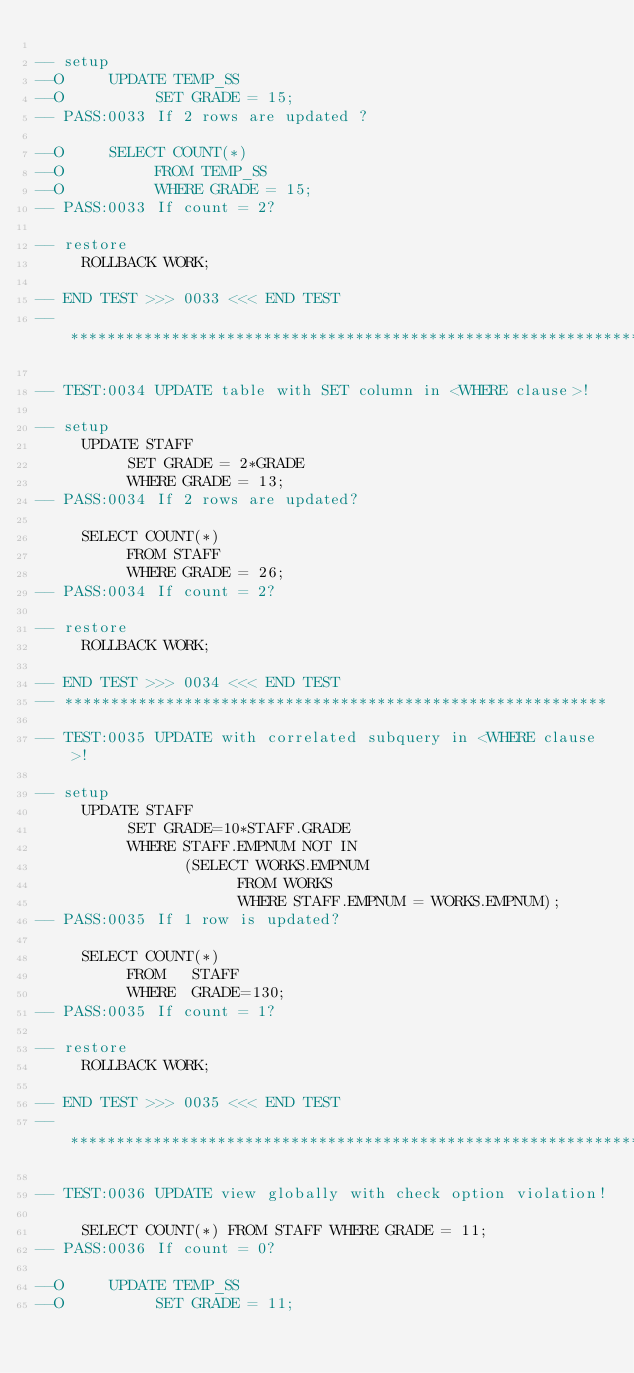<code> <loc_0><loc_0><loc_500><loc_500><_SQL_>
-- setup
--O     UPDATE TEMP_SS
--O          SET GRADE = 15;
-- PASS:0033 If 2 rows are updated ?

--O     SELECT COUNT(*)
--O          FROM TEMP_SS
--O          WHERE GRADE = 15;
-- PASS:0033 If count = 2?

-- restore
     ROLLBACK WORK;

-- END TEST >>> 0033 <<< END TEST
-- ***************************************************************

-- TEST:0034 UPDATE table with SET column in <WHERE clause>!

-- setup
     UPDATE STAFF
          SET GRADE = 2*GRADE
          WHERE GRADE = 13;
-- PASS:0034 If 2 rows are updated?

     SELECT COUNT(*)
          FROM STAFF
          WHERE GRADE = 26;
-- PASS:0034 If count = 2?

-- restore
     ROLLBACK WORK;

-- END TEST >>> 0034 <<< END TEST
-- ***********************************************************

-- TEST:0035 UPDATE with correlated subquery in <WHERE clause>!

-- setup
     UPDATE STAFF
          SET GRADE=10*STAFF.GRADE
          WHERE STAFF.EMPNUM NOT IN
                (SELECT WORKS.EMPNUM
                      FROM WORKS
                      WHERE STAFF.EMPNUM = WORKS.EMPNUM);
-- PASS:0035 If 1 row is updated?

     SELECT COUNT(*)
          FROM   STAFF
          WHERE  GRADE=130;
-- PASS:0035 If count = 1?

-- restore
     ROLLBACK WORK;

-- END TEST >>> 0035 <<< END TEST
-- ***************************************************************

-- TEST:0036 UPDATE view globally with check option violation!

     SELECT COUNT(*) FROM STAFF WHERE GRADE = 11;
-- PASS:0036 If count = 0?

--O     UPDATE TEMP_SS
--O          SET GRADE = 11;</code> 